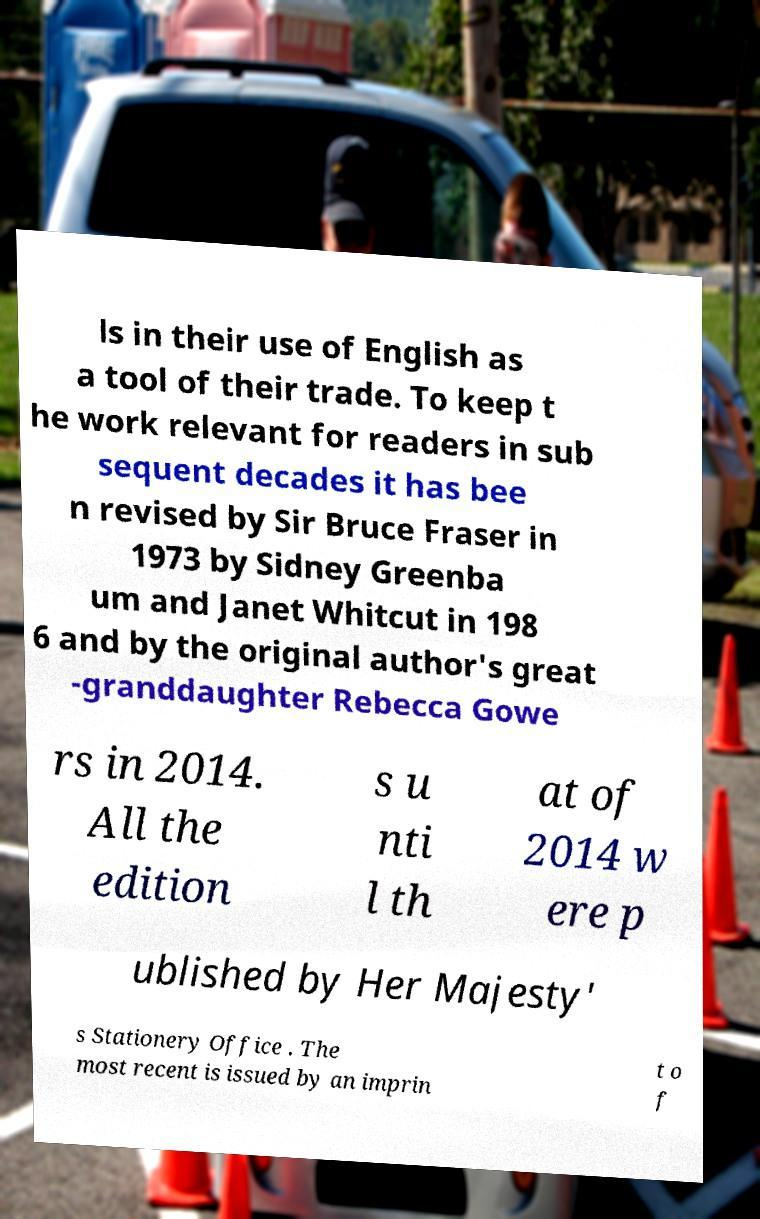Could you assist in decoding the text presented in this image and type it out clearly? ls in their use of English as a tool of their trade. To keep t he work relevant for readers in sub sequent decades it has bee n revised by Sir Bruce Fraser in 1973 by Sidney Greenba um and Janet Whitcut in 198 6 and by the original author's great -granddaughter Rebecca Gowe rs in 2014. All the edition s u nti l th at of 2014 w ere p ublished by Her Majesty' s Stationery Office . The most recent is issued by an imprin t o f 